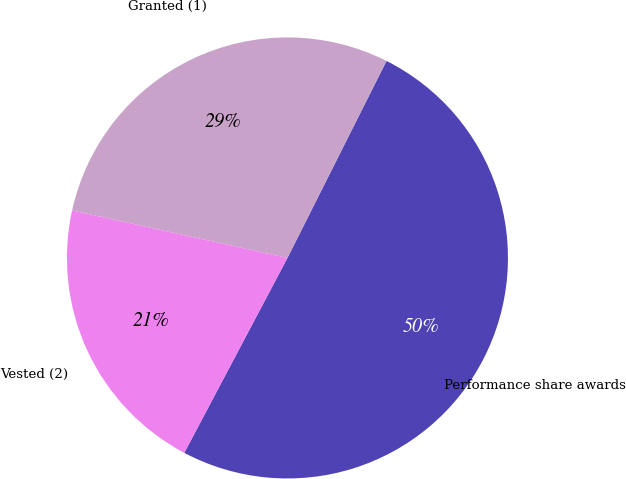<chart> <loc_0><loc_0><loc_500><loc_500><pie_chart><fcel>Performance share awards<fcel>Granted (1)<fcel>Vested (2)<nl><fcel>50.33%<fcel>28.96%<fcel>20.71%<nl></chart> 